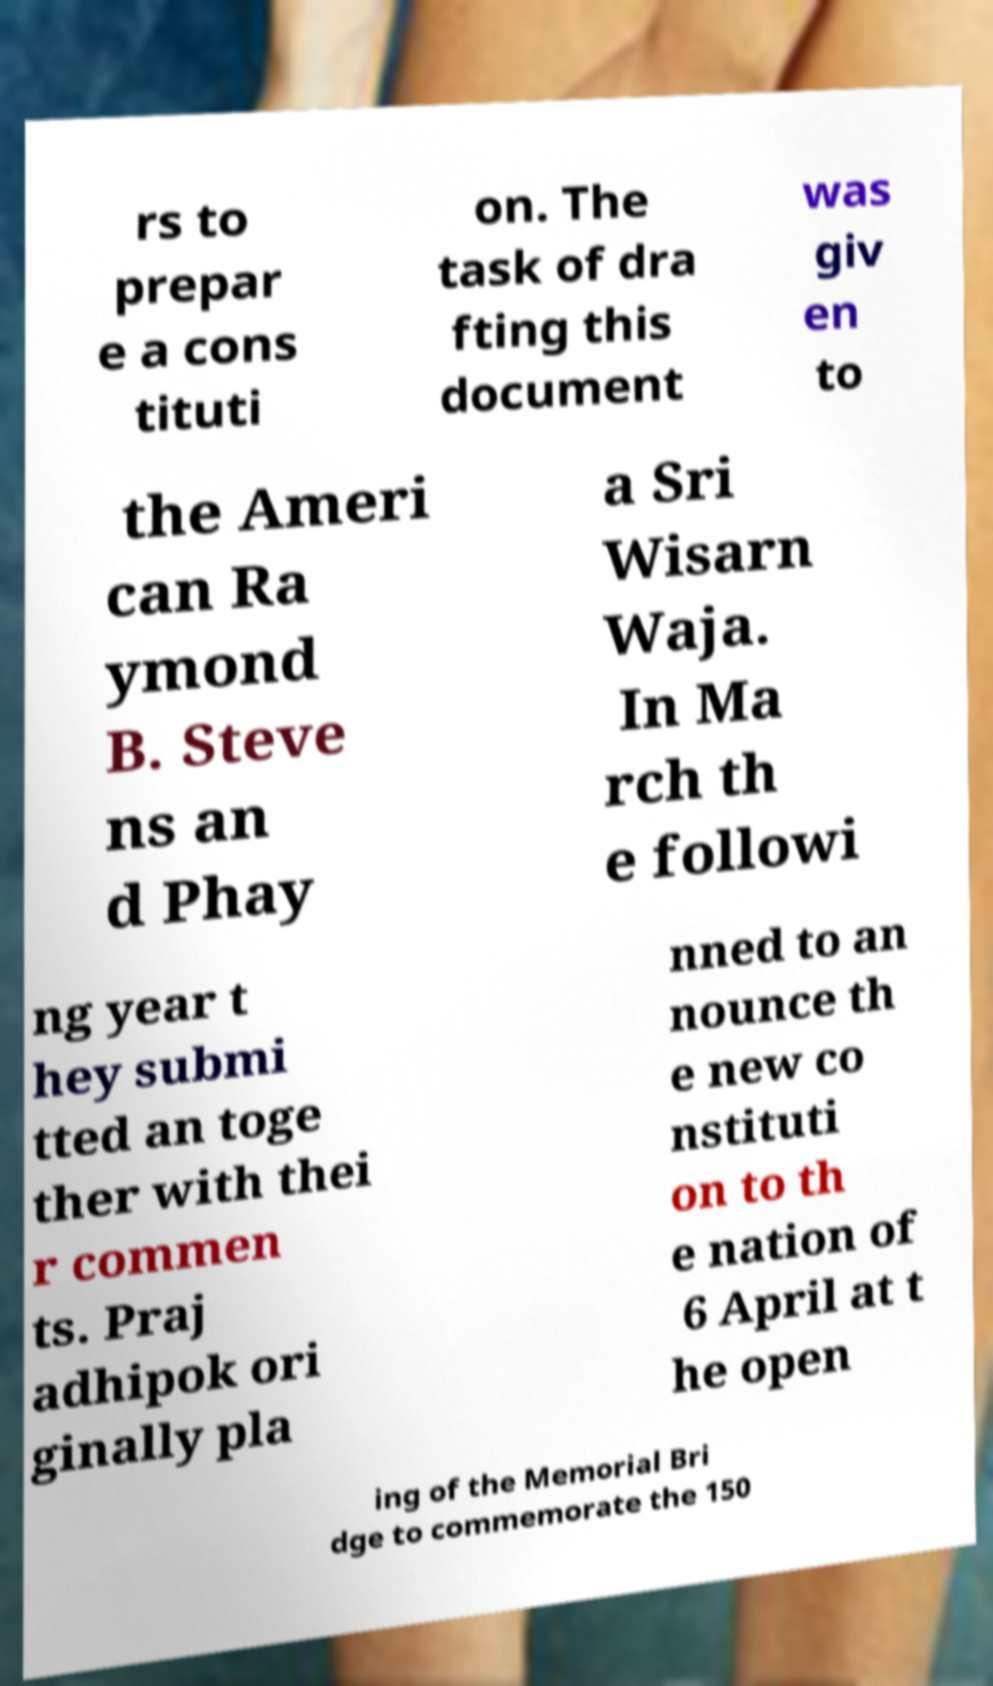For documentation purposes, I need the text within this image transcribed. Could you provide that? rs to prepar e a cons tituti on. The task of dra fting this document was giv en to the Ameri can Ra ymond B. Steve ns an d Phay a Sri Wisarn Waja. In Ma rch th e followi ng year t hey submi tted an toge ther with thei r commen ts. Praj adhipok ori ginally pla nned to an nounce th e new co nstituti on to th e nation of 6 April at t he open ing of the Memorial Bri dge to commemorate the 150 